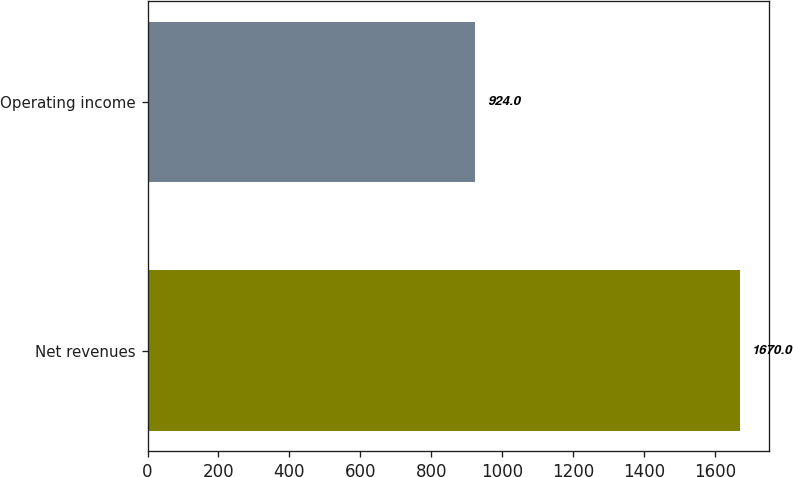<chart> <loc_0><loc_0><loc_500><loc_500><bar_chart><fcel>Net revenues<fcel>Operating income<nl><fcel>1670<fcel>924<nl></chart> 